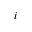Convert formula to latex. <formula><loc_0><loc_0><loc_500><loc_500>i</formula> 